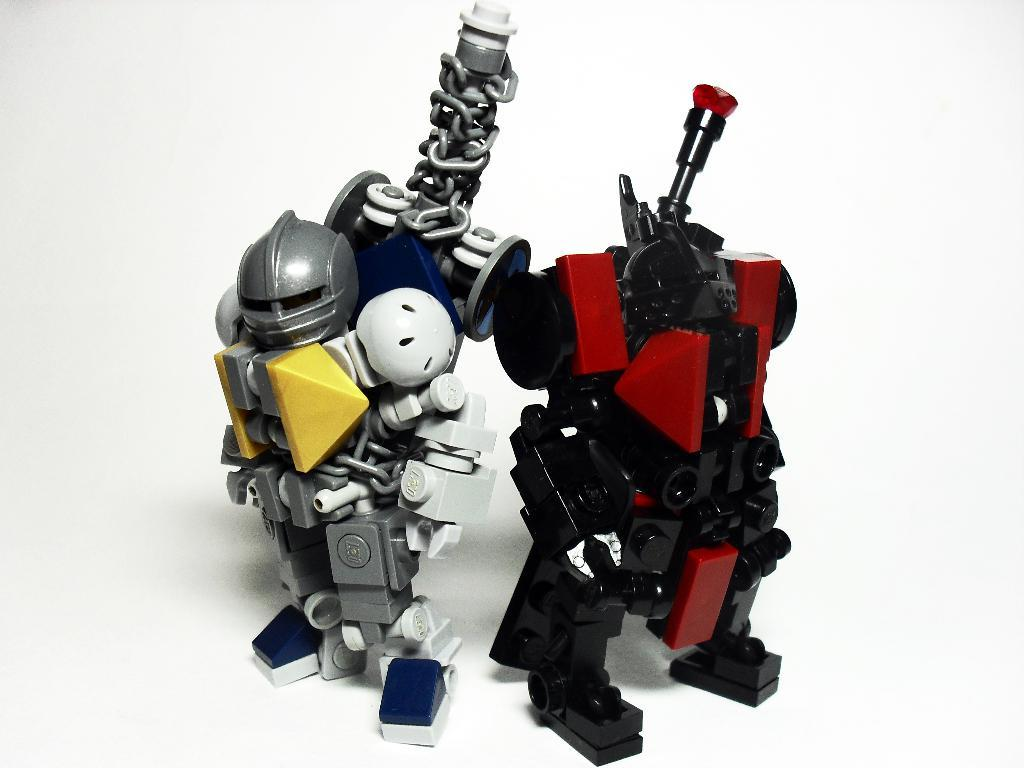How many toys can be seen in the image? There are two toys in the image. What can be observed about the background of the image? The background of the image is white. Is there a collar visible on the toys in the image? There is no collar present on the toys in the image. How long does it take for the toys to balance in the image? The toys do not balance in the image, and there is no mention of time or duration. 